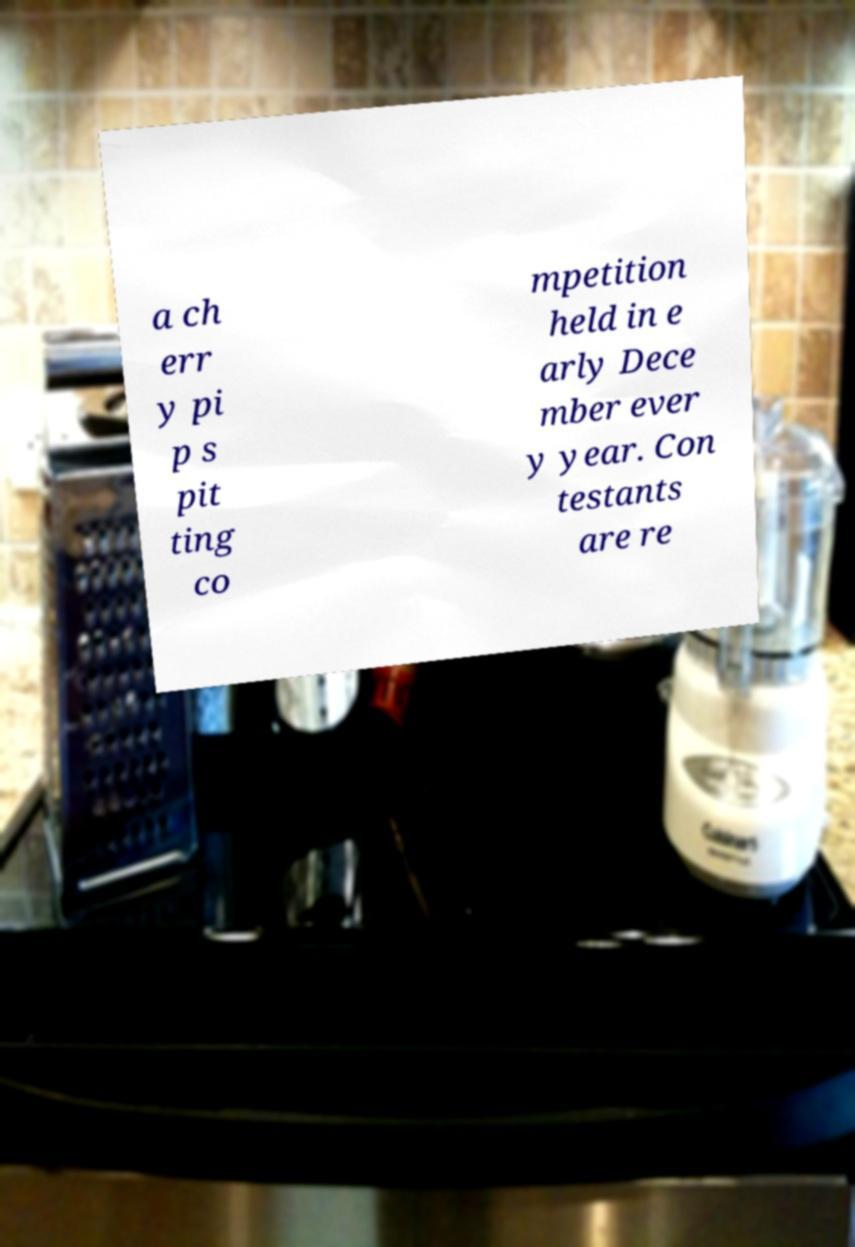Could you assist in decoding the text presented in this image and type it out clearly? a ch err y pi p s pit ting co mpetition held in e arly Dece mber ever y year. Con testants are re 